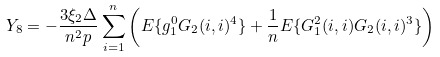<formula> <loc_0><loc_0><loc_500><loc_500>Y _ { 8 } = - \frac { 3 \xi _ { 2 } \Delta } { n ^ { 2 } p } \sum _ { i = 1 } ^ { n } \left ( { E } \{ g _ { 1 } ^ { 0 } G _ { 2 } ( i , i ) ^ { 4 } \} + \frac { 1 } { n } { E } \{ G ^ { 2 } _ { 1 } ( i , i ) G _ { 2 } ( i , i ) ^ { 3 } \} \right )</formula> 